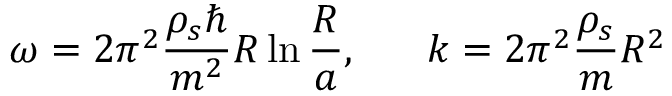<formula> <loc_0><loc_0><loc_500><loc_500>\omega = 2 \pi ^ { 2 } \frac { \rho _ { s } } { m ^ { 2 } } R \ln \frac { R } { a } , k = 2 \pi ^ { 2 } \frac { \rho _ { s } } { m } R ^ { 2 }</formula> 